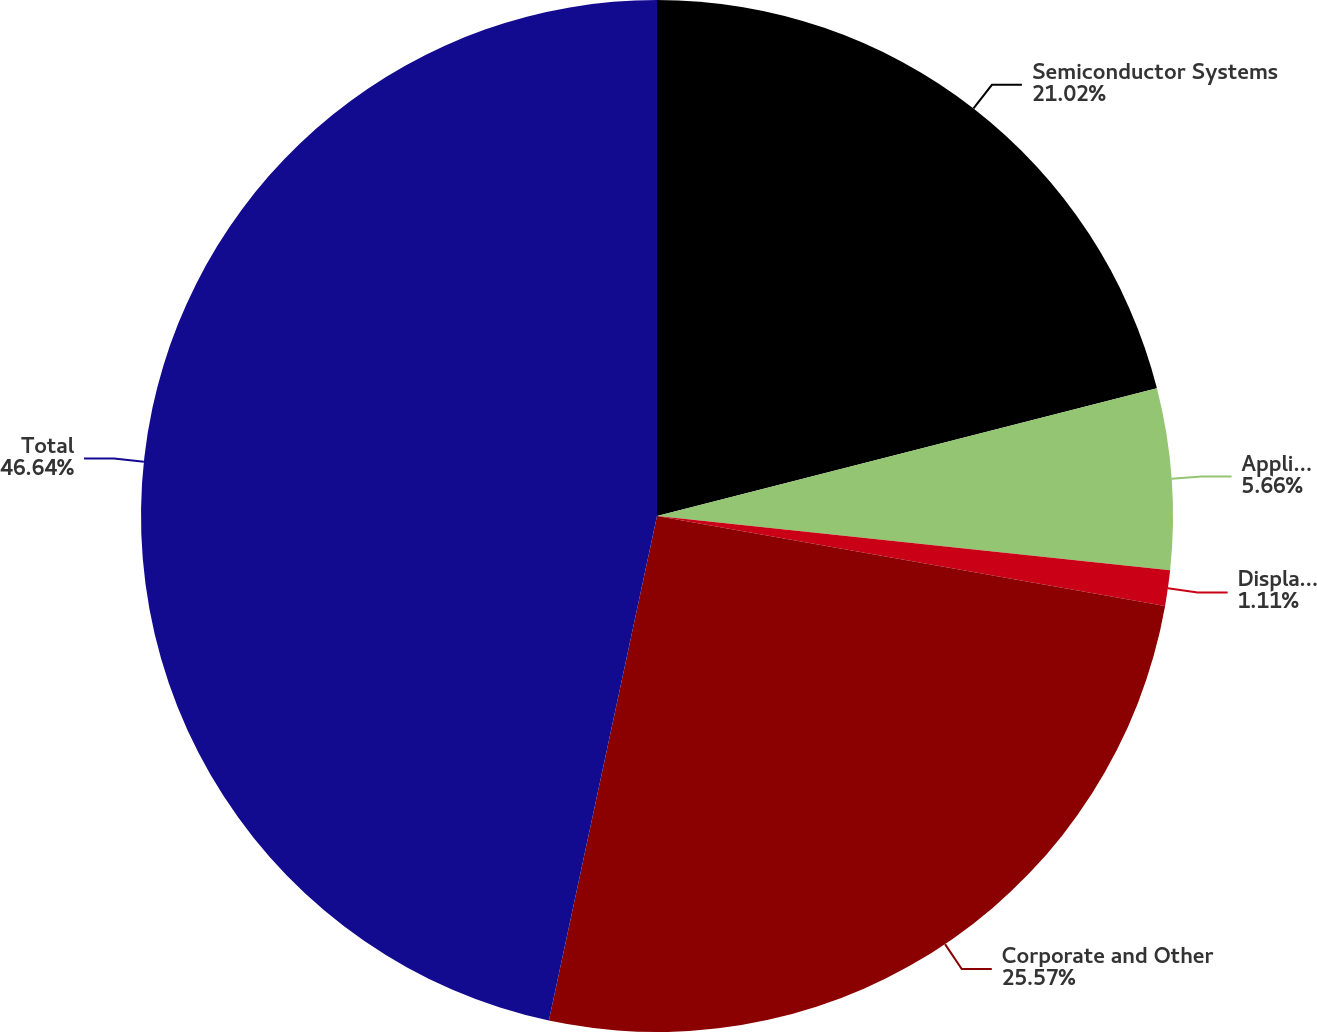Convert chart. <chart><loc_0><loc_0><loc_500><loc_500><pie_chart><fcel>Semiconductor Systems<fcel>Applied Global Services<fcel>Display and Adjacent Markets<fcel>Corporate and Other<fcel>Total<nl><fcel>21.02%<fcel>5.66%<fcel>1.11%<fcel>25.57%<fcel>46.64%<nl></chart> 